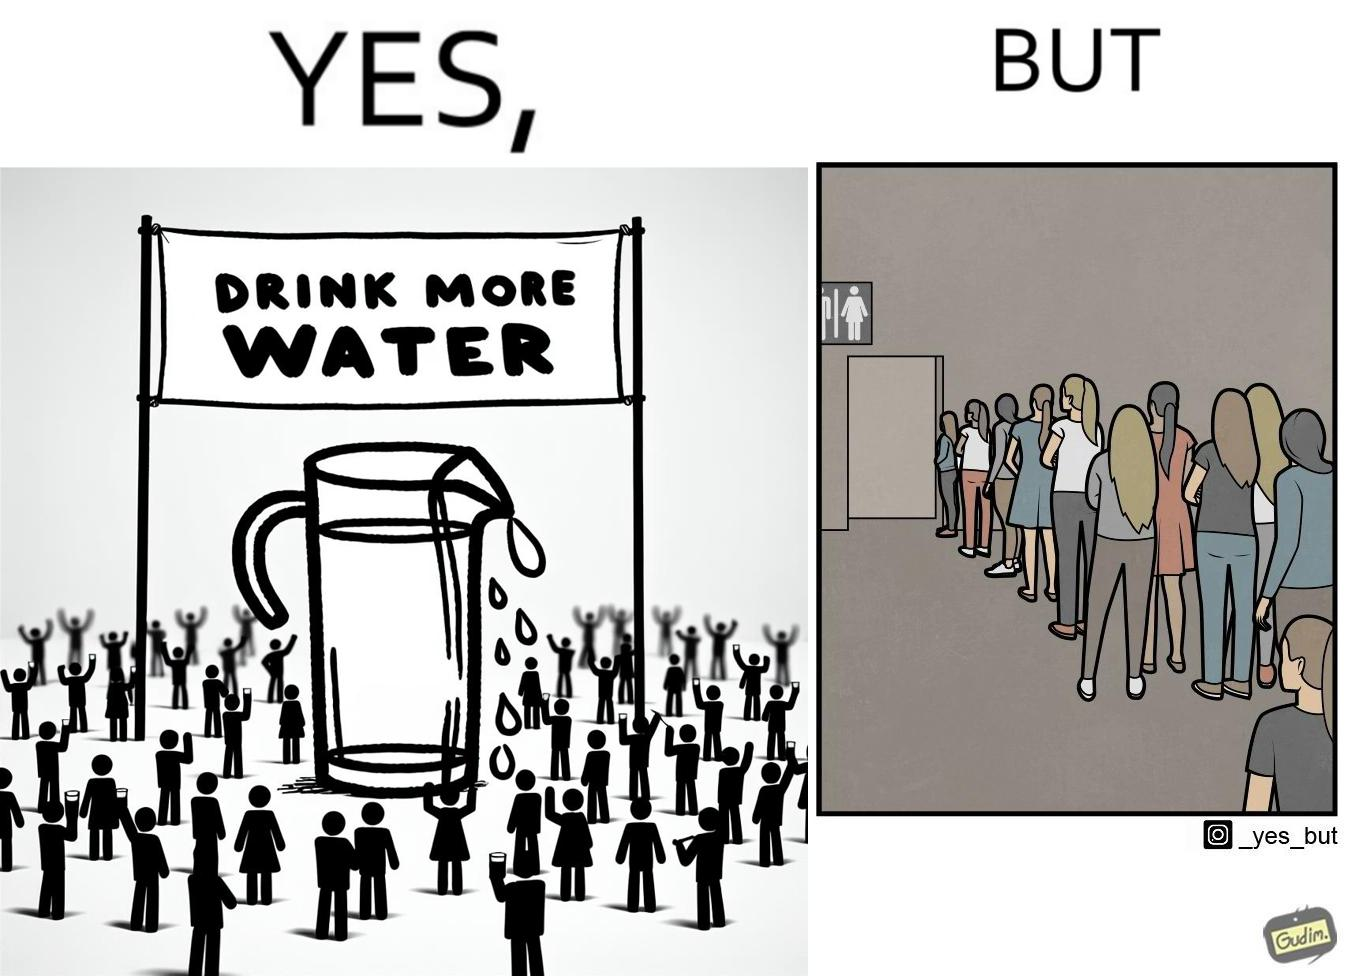Would you classify this image as satirical? Yes, this image is satirical. 